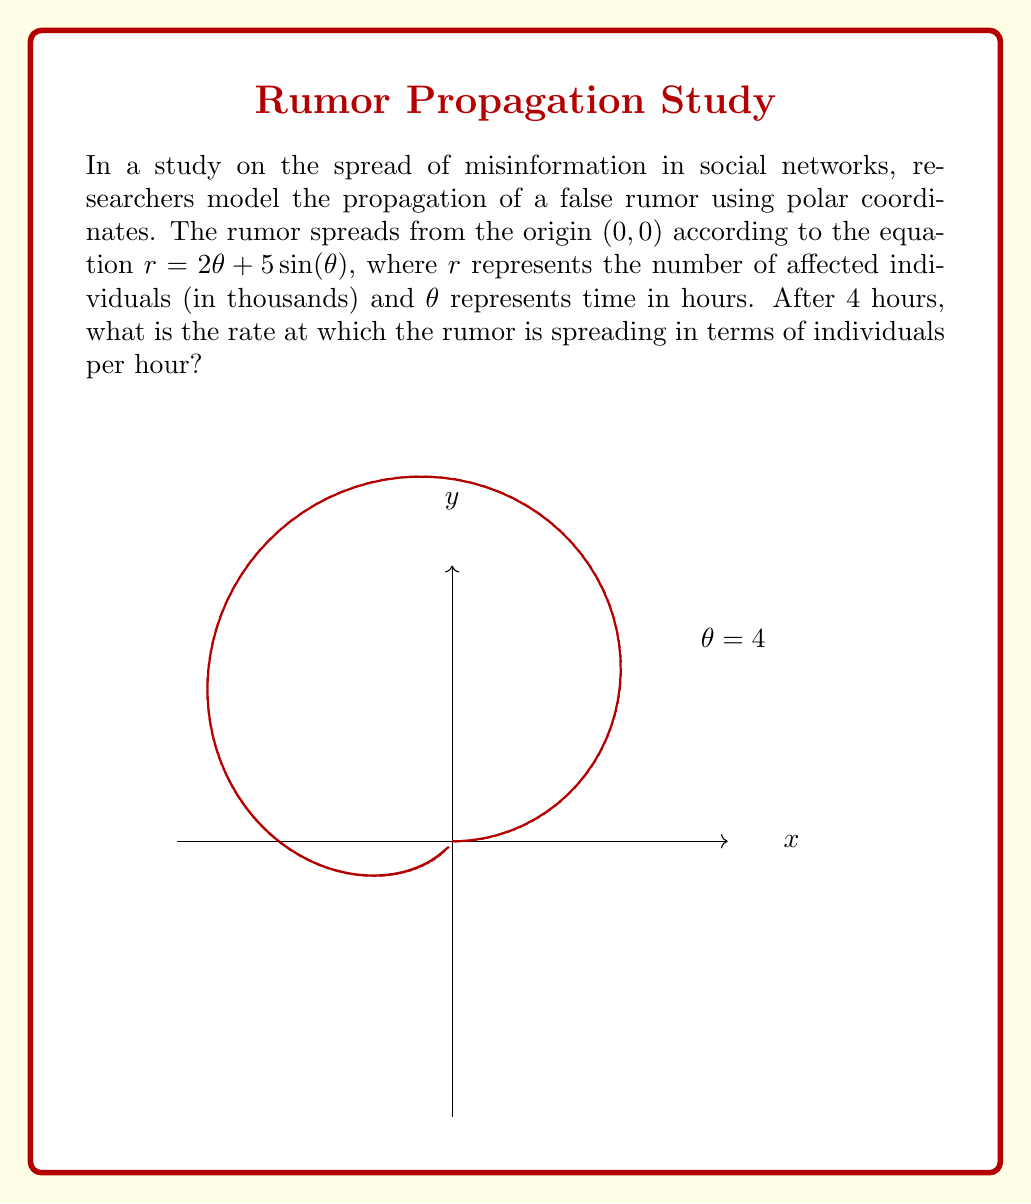Show me your answer to this math problem. To solve this problem, we need to follow these steps:

1) The spread of the rumor is given by the equation $r = 2\theta + 5\sin(\theta)$.

2) To find the rate of spread at $\theta = 4$, we need to calculate $\frac{dr}{d\theta}$ at this point.

3) Let's differentiate the equation with respect to $\theta$:

   $$\frac{dr}{d\theta} = 2 + 5\cos(\theta)$$

4) Now, we evaluate this at $\theta = 4$:

   $$\left.\frac{dr}{d\theta}\right|_{\theta=4} = 2 + 5\cos(4)$$

5) Calculate $\cos(4)$:
   
   $\cos(4) \approx -0.6536$

6) Substitute this value:

   $$\left.\frac{dr}{d\theta}\right|_{\theta=4} = 2 + 5(-0.6536) = 2 - 3.268 = -1.268$$

7) Remember that $r$ is in thousands of individuals and $\theta$ is in hours. So, this rate is in thousands of individuals per hour.

8) Convert to individuals per hour:

   $-1.268 * 1000 = -1268$ individuals/hour

The negative sign indicates that the rate of spread is decreasing at this point.
Answer: -1268 individuals/hour 